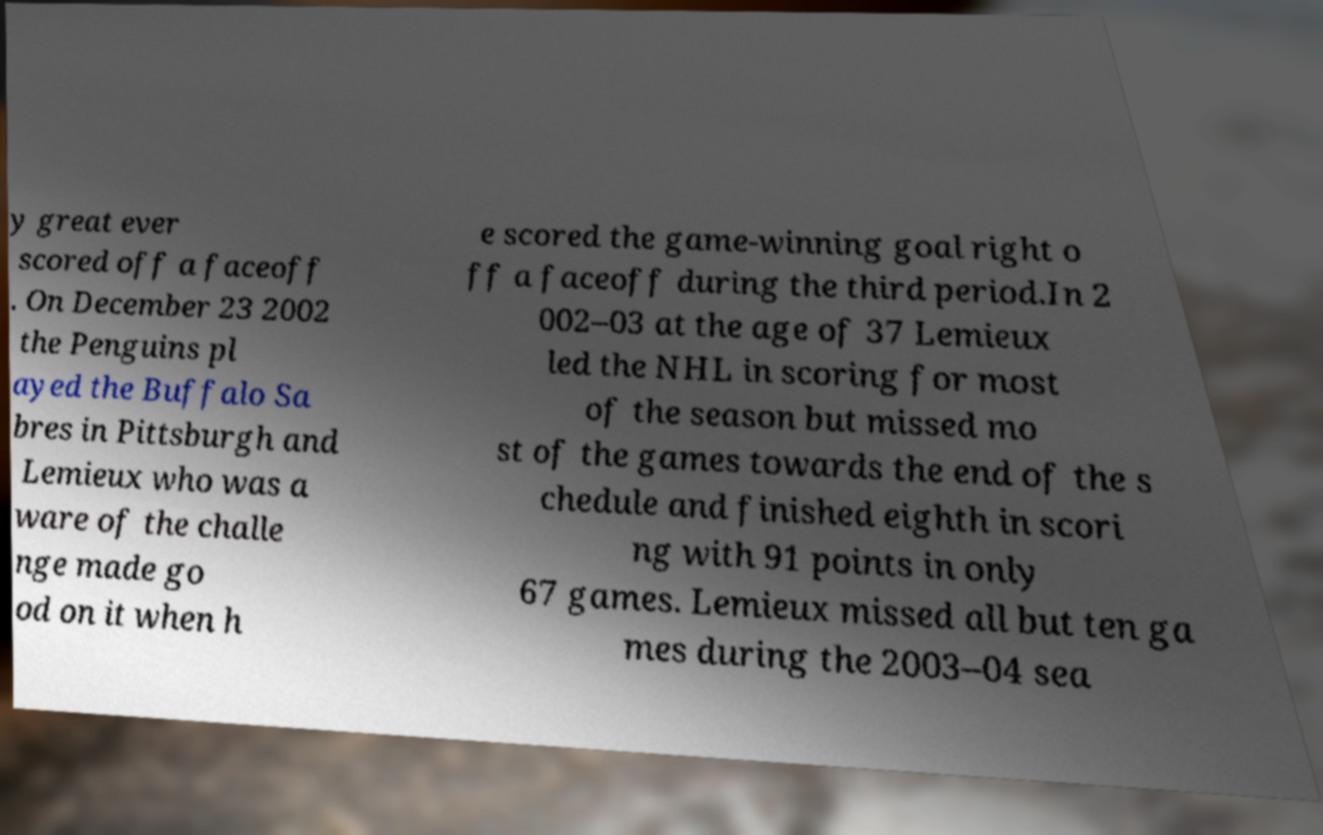Could you assist in decoding the text presented in this image and type it out clearly? y great ever scored off a faceoff . On December 23 2002 the Penguins pl ayed the Buffalo Sa bres in Pittsburgh and Lemieux who was a ware of the challe nge made go od on it when h e scored the game-winning goal right o ff a faceoff during the third period.In 2 002–03 at the age of 37 Lemieux led the NHL in scoring for most of the season but missed mo st of the games towards the end of the s chedule and finished eighth in scori ng with 91 points in only 67 games. Lemieux missed all but ten ga mes during the 2003–04 sea 